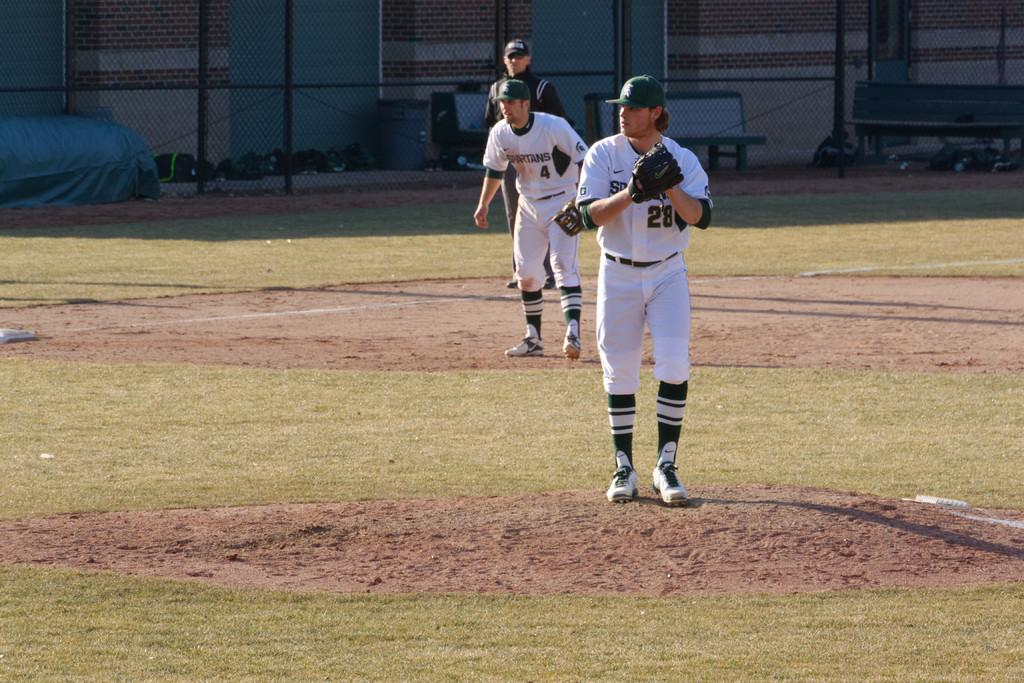Provide a one-sentence caption for the provided image. Player number 28 about to pitch as number 4 watches on. 